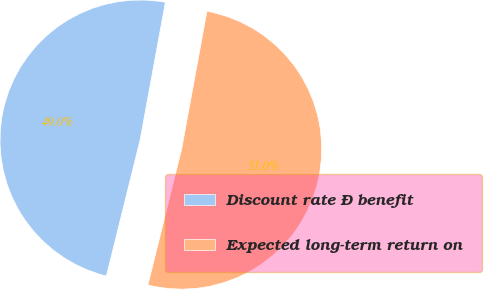Convert chart to OTSL. <chart><loc_0><loc_0><loc_500><loc_500><pie_chart><fcel>Discount rate Ð benefit<fcel>Expected long-term return on<nl><fcel>49.02%<fcel>50.98%<nl></chart> 